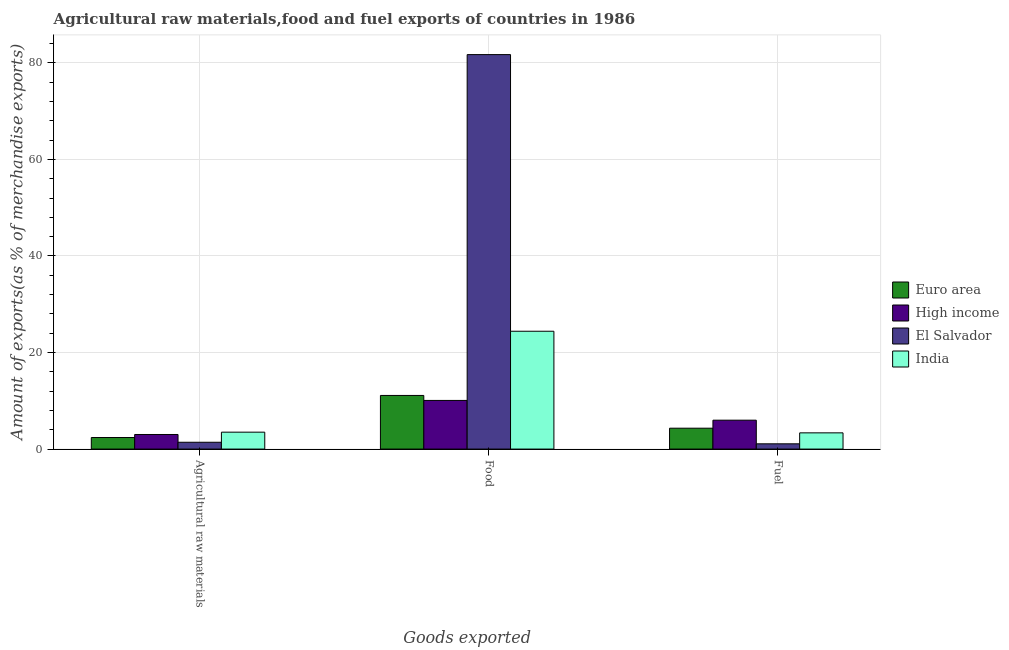How many groups of bars are there?
Your answer should be very brief. 3. Are the number of bars on each tick of the X-axis equal?
Provide a short and direct response. Yes. How many bars are there on the 1st tick from the left?
Provide a short and direct response. 4. What is the label of the 3rd group of bars from the left?
Offer a terse response. Fuel. What is the percentage of food exports in India?
Offer a very short reply. 24.41. Across all countries, what is the maximum percentage of food exports?
Provide a succinct answer. 81.72. Across all countries, what is the minimum percentage of food exports?
Provide a succinct answer. 10.08. In which country was the percentage of food exports maximum?
Your answer should be very brief. El Salvador. What is the total percentage of fuel exports in the graph?
Make the answer very short. 14.77. What is the difference between the percentage of food exports in El Salvador and that in Euro area?
Ensure brevity in your answer.  70.61. What is the difference between the percentage of fuel exports in High income and the percentage of food exports in El Salvador?
Your answer should be very brief. -75.74. What is the average percentage of raw materials exports per country?
Offer a terse response. 2.58. What is the difference between the percentage of food exports and percentage of raw materials exports in El Salvador?
Offer a very short reply. 80.31. In how many countries, is the percentage of food exports greater than 32 %?
Give a very brief answer. 1. What is the ratio of the percentage of fuel exports in Euro area to that in India?
Give a very brief answer. 1.29. Is the percentage of fuel exports in Euro area less than that in India?
Offer a terse response. No. What is the difference between the highest and the second highest percentage of fuel exports?
Your answer should be compact. 1.66. What is the difference between the highest and the lowest percentage of food exports?
Make the answer very short. 71.64. In how many countries, is the percentage of raw materials exports greater than the average percentage of raw materials exports taken over all countries?
Provide a short and direct response. 2. What does the 3rd bar from the left in Fuel represents?
Your answer should be very brief. El Salvador. What does the 2nd bar from the right in Fuel represents?
Make the answer very short. El Salvador. What is the difference between two consecutive major ticks on the Y-axis?
Keep it short and to the point. 20. Does the graph contain any zero values?
Give a very brief answer. No. Does the graph contain grids?
Provide a succinct answer. Yes. What is the title of the graph?
Provide a succinct answer. Agricultural raw materials,food and fuel exports of countries in 1986. What is the label or title of the X-axis?
Make the answer very short. Goods exported. What is the label or title of the Y-axis?
Provide a succinct answer. Amount of exports(as % of merchandise exports). What is the Amount of exports(as % of merchandise exports) in Euro area in Agricultural raw materials?
Your answer should be very brief. 2.39. What is the Amount of exports(as % of merchandise exports) in High income in Agricultural raw materials?
Provide a succinct answer. 3.02. What is the Amount of exports(as % of merchandise exports) in El Salvador in Agricultural raw materials?
Give a very brief answer. 1.41. What is the Amount of exports(as % of merchandise exports) in India in Agricultural raw materials?
Keep it short and to the point. 3.5. What is the Amount of exports(as % of merchandise exports) of Euro area in Food?
Provide a succinct answer. 11.11. What is the Amount of exports(as % of merchandise exports) in High income in Food?
Make the answer very short. 10.08. What is the Amount of exports(as % of merchandise exports) of El Salvador in Food?
Your answer should be very brief. 81.72. What is the Amount of exports(as % of merchandise exports) of India in Food?
Give a very brief answer. 24.41. What is the Amount of exports(as % of merchandise exports) of Euro area in Fuel?
Provide a succinct answer. 4.33. What is the Amount of exports(as % of merchandise exports) of High income in Fuel?
Offer a very short reply. 5.99. What is the Amount of exports(as % of merchandise exports) of El Salvador in Fuel?
Provide a succinct answer. 1.09. What is the Amount of exports(as % of merchandise exports) in India in Fuel?
Provide a short and direct response. 3.36. Across all Goods exported, what is the maximum Amount of exports(as % of merchandise exports) in Euro area?
Keep it short and to the point. 11.11. Across all Goods exported, what is the maximum Amount of exports(as % of merchandise exports) of High income?
Your response must be concise. 10.08. Across all Goods exported, what is the maximum Amount of exports(as % of merchandise exports) in El Salvador?
Your answer should be compact. 81.72. Across all Goods exported, what is the maximum Amount of exports(as % of merchandise exports) in India?
Your answer should be very brief. 24.41. Across all Goods exported, what is the minimum Amount of exports(as % of merchandise exports) of Euro area?
Your answer should be compact. 2.39. Across all Goods exported, what is the minimum Amount of exports(as % of merchandise exports) in High income?
Offer a very short reply. 3.02. Across all Goods exported, what is the minimum Amount of exports(as % of merchandise exports) of El Salvador?
Keep it short and to the point. 1.09. Across all Goods exported, what is the minimum Amount of exports(as % of merchandise exports) of India?
Provide a succinct answer. 3.36. What is the total Amount of exports(as % of merchandise exports) in Euro area in the graph?
Your response must be concise. 17.83. What is the total Amount of exports(as % of merchandise exports) in High income in the graph?
Offer a very short reply. 19.08. What is the total Amount of exports(as % of merchandise exports) of El Salvador in the graph?
Your answer should be very brief. 84.22. What is the total Amount of exports(as % of merchandise exports) of India in the graph?
Ensure brevity in your answer.  31.28. What is the difference between the Amount of exports(as % of merchandise exports) of Euro area in Agricultural raw materials and that in Food?
Offer a terse response. -8.72. What is the difference between the Amount of exports(as % of merchandise exports) of High income in Agricultural raw materials and that in Food?
Your answer should be very brief. -7.06. What is the difference between the Amount of exports(as % of merchandise exports) in El Salvador in Agricultural raw materials and that in Food?
Give a very brief answer. -80.31. What is the difference between the Amount of exports(as % of merchandise exports) in India in Agricultural raw materials and that in Food?
Provide a short and direct response. -20.91. What is the difference between the Amount of exports(as % of merchandise exports) in Euro area in Agricultural raw materials and that in Fuel?
Offer a very short reply. -1.93. What is the difference between the Amount of exports(as % of merchandise exports) of High income in Agricultural raw materials and that in Fuel?
Make the answer very short. -2.96. What is the difference between the Amount of exports(as % of merchandise exports) of El Salvador in Agricultural raw materials and that in Fuel?
Offer a terse response. 0.32. What is the difference between the Amount of exports(as % of merchandise exports) in India in Agricultural raw materials and that in Fuel?
Offer a very short reply. 0.14. What is the difference between the Amount of exports(as % of merchandise exports) in Euro area in Food and that in Fuel?
Provide a short and direct response. 6.78. What is the difference between the Amount of exports(as % of merchandise exports) in High income in Food and that in Fuel?
Keep it short and to the point. 4.09. What is the difference between the Amount of exports(as % of merchandise exports) of El Salvador in Food and that in Fuel?
Offer a terse response. 80.63. What is the difference between the Amount of exports(as % of merchandise exports) of India in Food and that in Fuel?
Ensure brevity in your answer.  21.05. What is the difference between the Amount of exports(as % of merchandise exports) in Euro area in Agricultural raw materials and the Amount of exports(as % of merchandise exports) in High income in Food?
Give a very brief answer. -7.68. What is the difference between the Amount of exports(as % of merchandise exports) in Euro area in Agricultural raw materials and the Amount of exports(as % of merchandise exports) in El Salvador in Food?
Provide a succinct answer. -79.33. What is the difference between the Amount of exports(as % of merchandise exports) of Euro area in Agricultural raw materials and the Amount of exports(as % of merchandise exports) of India in Food?
Provide a short and direct response. -22.02. What is the difference between the Amount of exports(as % of merchandise exports) of High income in Agricultural raw materials and the Amount of exports(as % of merchandise exports) of El Salvador in Food?
Ensure brevity in your answer.  -78.7. What is the difference between the Amount of exports(as % of merchandise exports) in High income in Agricultural raw materials and the Amount of exports(as % of merchandise exports) in India in Food?
Your answer should be very brief. -21.39. What is the difference between the Amount of exports(as % of merchandise exports) in El Salvador in Agricultural raw materials and the Amount of exports(as % of merchandise exports) in India in Food?
Your answer should be compact. -23. What is the difference between the Amount of exports(as % of merchandise exports) of Euro area in Agricultural raw materials and the Amount of exports(as % of merchandise exports) of High income in Fuel?
Make the answer very short. -3.59. What is the difference between the Amount of exports(as % of merchandise exports) in Euro area in Agricultural raw materials and the Amount of exports(as % of merchandise exports) in El Salvador in Fuel?
Offer a terse response. 1.3. What is the difference between the Amount of exports(as % of merchandise exports) in Euro area in Agricultural raw materials and the Amount of exports(as % of merchandise exports) in India in Fuel?
Your response must be concise. -0.97. What is the difference between the Amount of exports(as % of merchandise exports) of High income in Agricultural raw materials and the Amount of exports(as % of merchandise exports) of El Salvador in Fuel?
Keep it short and to the point. 1.93. What is the difference between the Amount of exports(as % of merchandise exports) of High income in Agricultural raw materials and the Amount of exports(as % of merchandise exports) of India in Fuel?
Ensure brevity in your answer.  -0.34. What is the difference between the Amount of exports(as % of merchandise exports) of El Salvador in Agricultural raw materials and the Amount of exports(as % of merchandise exports) of India in Fuel?
Offer a very short reply. -1.95. What is the difference between the Amount of exports(as % of merchandise exports) in Euro area in Food and the Amount of exports(as % of merchandise exports) in High income in Fuel?
Your answer should be compact. 5.12. What is the difference between the Amount of exports(as % of merchandise exports) of Euro area in Food and the Amount of exports(as % of merchandise exports) of El Salvador in Fuel?
Your response must be concise. 10.02. What is the difference between the Amount of exports(as % of merchandise exports) in Euro area in Food and the Amount of exports(as % of merchandise exports) in India in Fuel?
Your answer should be very brief. 7.75. What is the difference between the Amount of exports(as % of merchandise exports) in High income in Food and the Amount of exports(as % of merchandise exports) in El Salvador in Fuel?
Your answer should be very brief. 8.99. What is the difference between the Amount of exports(as % of merchandise exports) of High income in Food and the Amount of exports(as % of merchandise exports) of India in Fuel?
Your answer should be very brief. 6.72. What is the difference between the Amount of exports(as % of merchandise exports) of El Salvador in Food and the Amount of exports(as % of merchandise exports) of India in Fuel?
Your answer should be compact. 78.36. What is the average Amount of exports(as % of merchandise exports) in Euro area per Goods exported?
Ensure brevity in your answer.  5.94. What is the average Amount of exports(as % of merchandise exports) in High income per Goods exported?
Give a very brief answer. 6.36. What is the average Amount of exports(as % of merchandise exports) in El Salvador per Goods exported?
Your answer should be compact. 28.07. What is the average Amount of exports(as % of merchandise exports) of India per Goods exported?
Ensure brevity in your answer.  10.43. What is the difference between the Amount of exports(as % of merchandise exports) of Euro area and Amount of exports(as % of merchandise exports) of High income in Agricultural raw materials?
Provide a succinct answer. -0.63. What is the difference between the Amount of exports(as % of merchandise exports) of Euro area and Amount of exports(as % of merchandise exports) of El Salvador in Agricultural raw materials?
Provide a succinct answer. 0.98. What is the difference between the Amount of exports(as % of merchandise exports) in Euro area and Amount of exports(as % of merchandise exports) in India in Agricultural raw materials?
Give a very brief answer. -1.11. What is the difference between the Amount of exports(as % of merchandise exports) in High income and Amount of exports(as % of merchandise exports) in El Salvador in Agricultural raw materials?
Your answer should be very brief. 1.61. What is the difference between the Amount of exports(as % of merchandise exports) in High income and Amount of exports(as % of merchandise exports) in India in Agricultural raw materials?
Your answer should be compact. -0.48. What is the difference between the Amount of exports(as % of merchandise exports) in El Salvador and Amount of exports(as % of merchandise exports) in India in Agricultural raw materials?
Make the answer very short. -2.09. What is the difference between the Amount of exports(as % of merchandise exports) in Euro area and Amount of exports(as % of merchandise exports) in High income in Food?
Offer a very short reply. 1.03. What is the difference between the Amount of exports(as % of merchandise exports) of Euro area and Amount of exports(as % of merchandise exports) of El Salvador in Food?
Offer a very short reply. -70.61. What is the difference between the Amount of exports(as % of merchandise exports) in Euro area and Amount of exports(as % of merchandise exports) in India in Food?
Offer a terse response. -13.3. What is the difference between the Amount of exports(as % of merchandise exports) in High income and Amount of exports(as % of merchandise exports) in El Salvador in Food?
Give a very brief answer. -71.64. What is the difference between the Amount of exports(as % of merchandise exports) of High income and Amount of exports(as % of merchandise exports) of India in Food?
Your answer should be very brief. -14.33. What is the difference between the Amount of exports(as % of merchandise exports) of El Salvador and Amount of exports(as % of merchandise exports) of India in Food?
Give a very brief answer. 57.31. What is the difference between the Amount of exports(as % of merchandise exports) of Euro area and Amount of exports(as % of merchandise exports) of High income in Fuel?
Offer a very short reply. -1.66. What is the difference between the Amount of exports(as % of merchandise exports) of Euro area and Amount of exports(as % of merchandise exports) of El Salvador in Fuel?
Make the answer very short. 3.24. What is the difference between the Amount of exports(as % of merchandise exports) of Euro area and Amount of exports(as % of merchandise exports) of India in Fuel?
Keep it short and to the point. 0.96. What is the difference between the Amount of exports(as % of merchandise exports) of High income and Amount of exports(as % of merchandise exports) of El Salvador in Fuel?
Offer a terse response. 4.9. What is the difference between the Amount of exports(as % of merchandise exports) in High income and Amount of exports(as % of merchandise exports) in India in Fuel?
Your response must be concise. 2.62. What is the difference between the Amount of exports(as % of merchandise exports) of El Salvador and Amount of exports(as % of merchandise exports) of India in Fuel?
Ensure brevity in your answer.  -2.27. What is the ratio of the Amount of exports(as % of merchandise exports) in Euro area in Agricultural raw materials to that in Food?
Provide a short and direct response. 0.22. What is the ratio of the Amount of exports(as % of merchandise exports) in High income in Agricultural raw materials to that in Food?
Keep it short and to the point. 0.3. What is the ratio of the Amount of exports(as % of merchandise exports) of El Salvador in Agricultural raw materials to that in Food?
Offer a very short reply. 0.02. What is the ratio of the Amount of exports(as % of merchandise exports) of India in Agricultural raw materials to that in Food?
Offer a very short reply. 0.14. What is the ratio of the Amount of exports(as % of merchandise exports) in Euro area in Agricultural raw materials to that in Fuel?
Offer a terse response. 0.55. What is the ratio of the Amount of exports(as % of merchandise exports) in High income in Agricultural raw materials to that in Fuel?
Give a very brief answer. 0.5. What is the ratio of the Amount of exports(as % of merchandise exports) in El Salvador in Agricultural raw materials to that in Fuel?
Make the answer very short. 1.3. What is the ratio of the Amount of exports(as % of merchandise exports) of India in Agricultural raw materials to that in Fuel?
Your response must be concise. 1.04. What is the ratio of the Amount of exports(as % of merchandise exports) of Euro area in Food to that in Fuel?
Your response must be concise. 2.57. What is the ratio of the Amount of exports(as % of merchandise exports) in High income in Food to that in Fuel?
Offer a terse response. 1.68. What is the ratio of the Amount of exports(as % of merchandise exports) of El Salvador in Food to that in Fuel?
Offer a terse response. 74.97. What is the ratio of the Amount of exports(as % of merchandise exports) of India in Food to that in Fuel?
Provide a short and direct response. 7.26. What is the difference between the highest and the second highest Amount of exports(as % of merchandise exports) of Euro area?
Ensure brevity in your answer.  6.78. What is the difference between the highest and the second highest Amount of exports(as % of merchandise exports) of High income?
Offer a terse response. 4.09. What is the difference between the highest and the second highest Amount of exports(as % of merchandise exports) of El Salvador?
Keep it short and to the point. 80.31. What is the difference between the highest and the second highest Amount of exports(as % of merchandise exports) of India?
Give a very brief answer. 20.91. What is the difference between the highest and the lowest Amount of exports(as % of merchandise exports) in Euro area?
Offer a terse response. 8.72. What is the difference between the highest and the lowest Amount of exports(as % of merchandise exports) of High income?
Give a very brief answer. 7.06. What is the difference between the highest and the lowest Amount of exports(as % of merchandise exports) of El Salvador?
Provide a succinct answer. 80.63. What is the difference between the highest and the lowest Amount of exports(as % of merchandise exports) of India?
Your response must be concise. 21.05. 